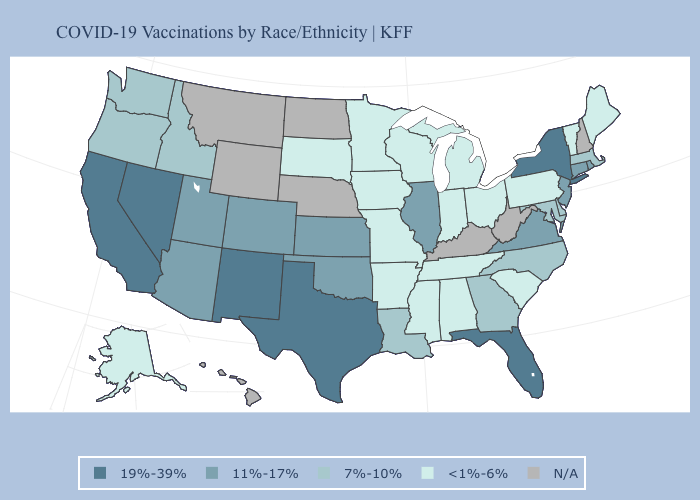Does Illinois have the highest value in the MidWest?
Write a very short answer. Yes. Does Pennsylvania have the lowest value in the USA?
Give a very brief answer. Yes. Name the states that have a value in the range N/A?
Write a very short answer. Hawaii, Kentucky, Montana, Nebraska, New Hampshire, North Dakota, West Virginia, Wyoming. Among the states that border New Mexico , does Texas have the highest value?
Concise answer only. Yes. What is the value of Iowa?
Short answer required. <1%-6%. Name the states that have a value in the range 11%-17%?
Short answer required. Arizona, Colorado, Connecticut, Illinois, Kansas, New Jersey, Oklahoma, Rhode Island, Utah, Virginia. What is the highest value in the USA?
Concise answer only. 19%-39%. Does Illinois have the lowest value in the USA?
Keep it brief. No. What is the value of Ohio?
Short answer required. <1%-6%. Name the states that have a value in the range <1%-6%?
Answer briefly. Alabama, Alaska, Arkansas, Indiana, Iowa, Maine, Michigan, Minnesota, Mississippi, Missouri, Ohio, Pennsylvania, South Carolina, South Dakota, Tennessee, Vermont, Wisconsin. What is the highest value in states that border Arizona?
Answer briefly. 19%-39%. What is the highest value in states that border Alabama?
Answer briefly. 19%-39%. Name the states that have a value in the range <1%-6%?
Give a very brief answer. Alabama, Alaska, Arkansas, Indiana, Iowa, Maine, Michigan, Minnesota, Mississippi, Missouri, Ohio, Pennsylvania, South Carolina, South Dakota, Tennessee, Vermont, Wisconsin. Name the states that have a value in the range <1%-6%?
Quick response, please. Alabama, Alaska, Arkansas, Indiana, Iowa, Maine, Michigan, Minnesota, Mississippi, Missouri, Ohio, Pennsylvania, South Carolina, South Dakota, Tennessee, Vermont, Wisconsin. 